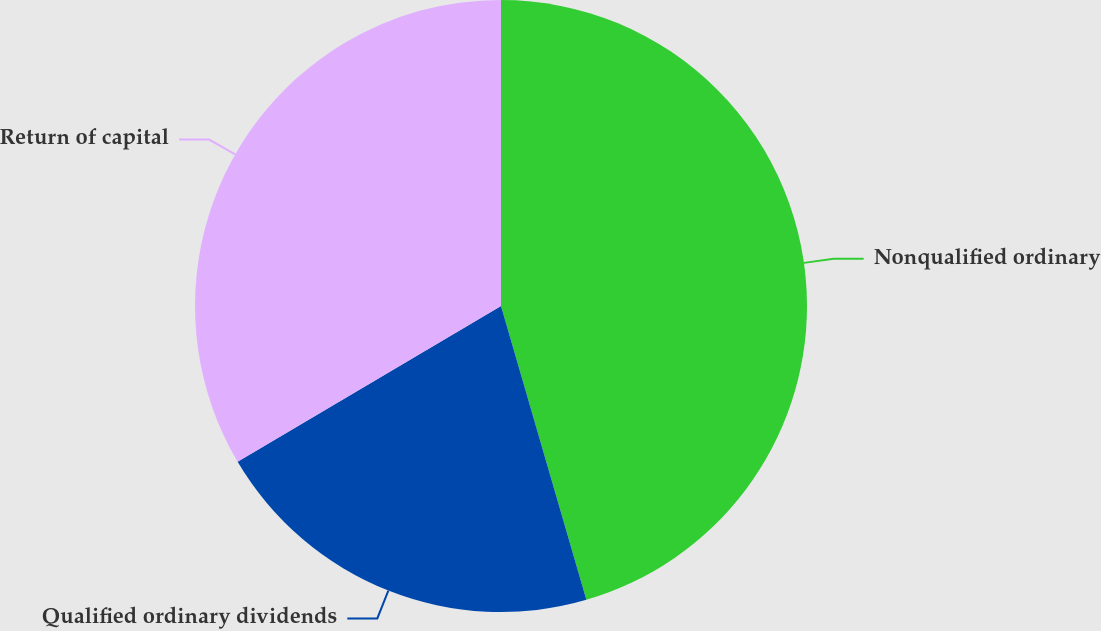Convert chart to OTSL. <chart><loc_0><loc_0><loc_500><loc_500><pie_chart><fcel>Nonqualified ordinary<fcel>Qualified ordinary dividends<fcel>Return of capital<nl><fcel>45.5%<fcel>21.0%<fcel>33.5%<nl></chart> 